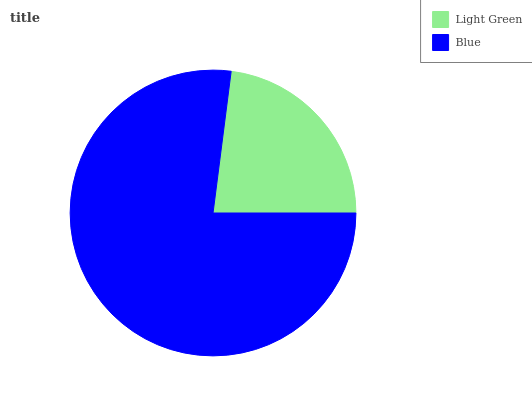Is Light Green the minimum?
Answer yes or no. Yes. Is Blue the maximum?
Answer yes or no. Yes. Is Blue the minimum?
Answer yes or no. No. Is Blue greater than Light Green?
Answer yes or no. Yes. Is Light Green less than Blue?
Answer yes or no. Yes. Is Light Green greater than Blue?
Answer yes or no. No. Is Blue less than Light Green?
Answer yes or no. No. Is Blue the high median?
Answer yes or no. Yes. Is Light Green the low median?
Answer yes or no. Yes. Is Light Green the high median?
Answer yes or no. No. Is Blue the low median?
Answer yes or no. No. 